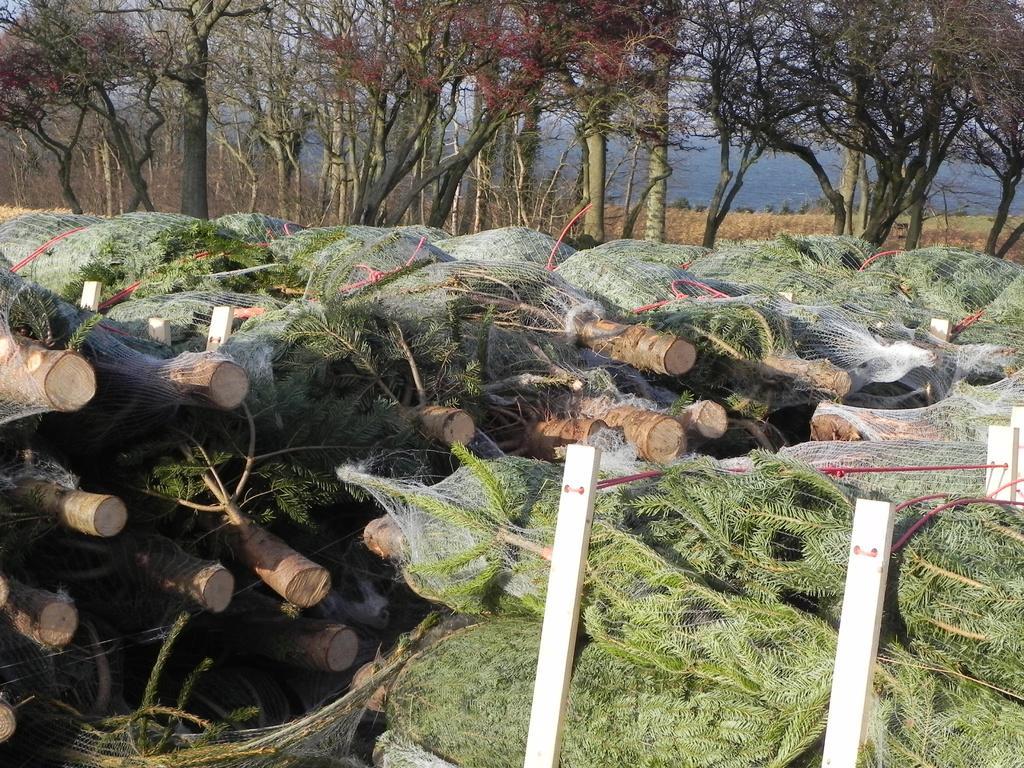Describe this image in one or two sentences. In this image, we can see huge stacks of logs and in the background, there are trees. 